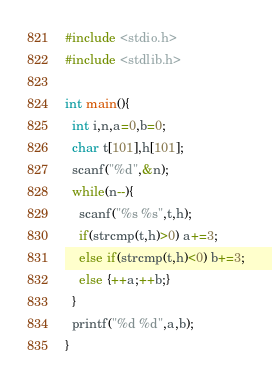<code> <loc_0><loc_0><loc_500><loc_500><_C_>#include <stdio.h>
#include <stdlib.h>

int main(){
  int i,n,a=0,b=0;
  char t[101],h[101];
  scanf("%d",&n);
  while(n--){
    scanf("%s %s",t,h);
    if(strcmp(t,h)>0) a+=3;
    else if(strcmp(t,h)<0) b+=3;
    else {++a;++b;}
  }
  printf("%d %d",a,b);
}</code> 